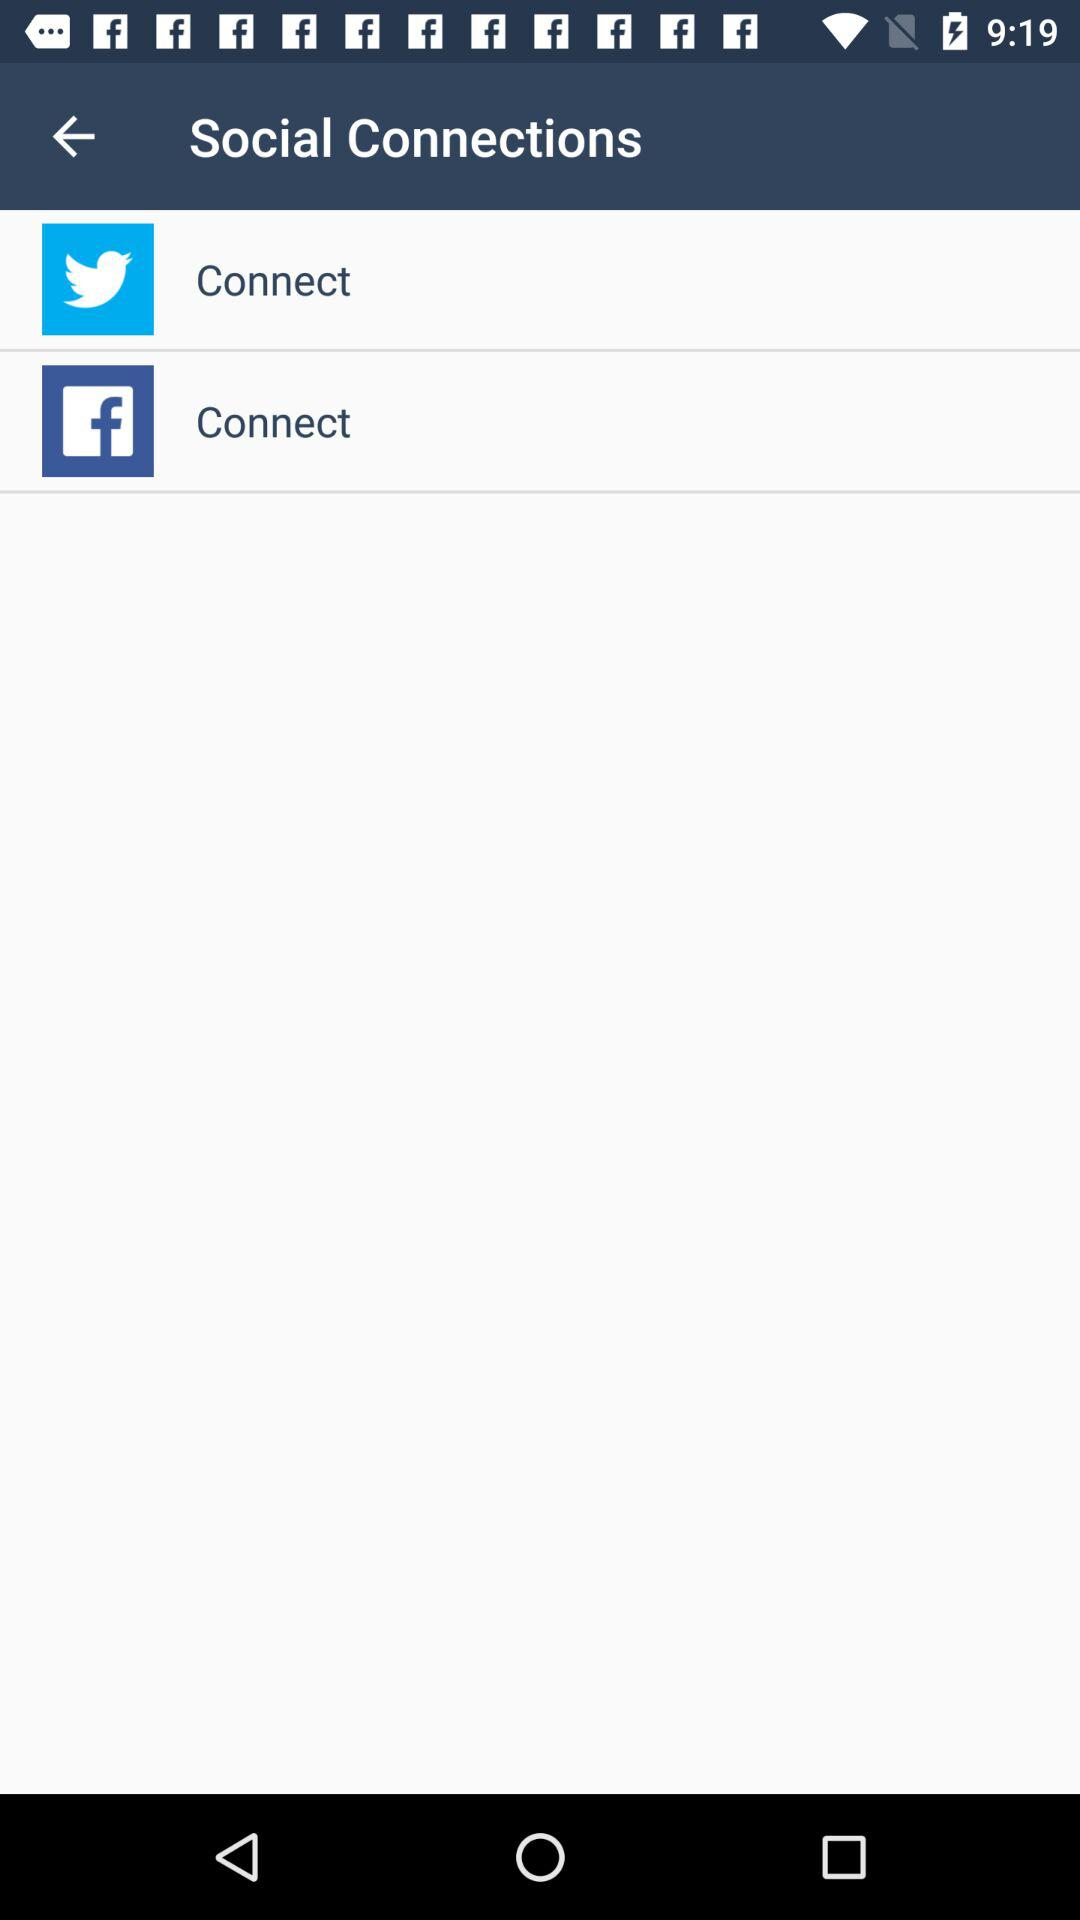What social accounts can I use to connect? The social accounts you can use to connect are "Twitter" and "Facebook". 